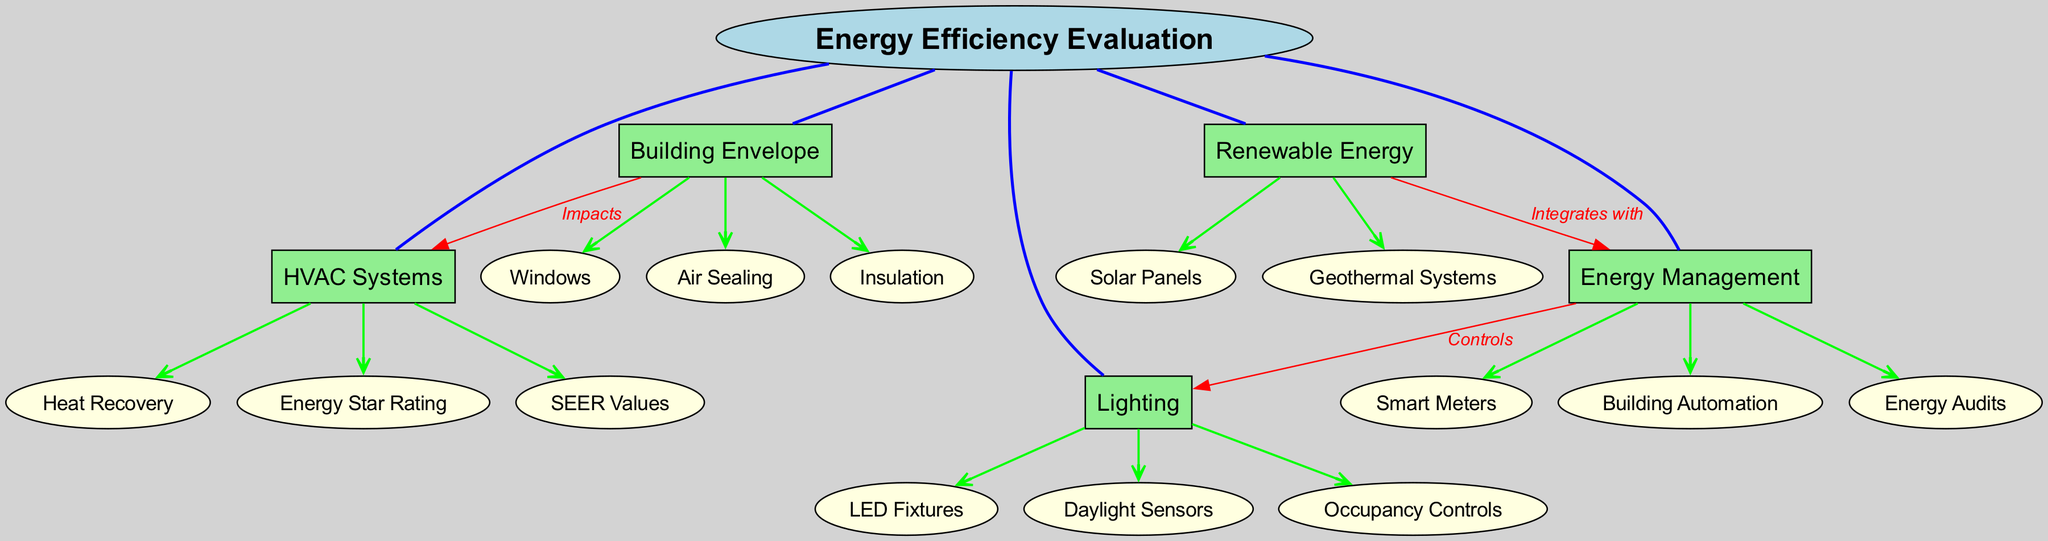What is the central concept of the diagram? The central concept is displayed prominently at the center of the diagram as "Energy Efficiency Evaluation".
Answer: Energy Efficiency Evaluation How many main categories are there? By counting the boxes branching out from the central concept, there are five main categories in total.
Answer: 5 Which subcategory is associated with "Building Envelope"? Looking under the "Building Envelope" category, "Insulation" is one of the subcategories listed.
Answer: Insulation What type of controls does "Energy Management" provide for "Lighting"? The connection from "Energy Management" to "Lighting" specifies that it provides "Controls" as identified in the diagram.
Answer: Controls Which renewable energy system is mentioned in the diagram? The "Renewable Energy" category lists "Solar Panels" as one of the systems described.
Answer: Solar Panels How does the "Building Envelope" impact "HVAC Systems"? The diagram states that "Building Envelope" has a direct impact on "HVAC Systems", indicating a relationship labeled as "Impacts".
Answer: Impacts What connects "Renewable Energy" and "Energy Management"? The diagram shows a relationship labeled "Integrates with" connecting "Renewable Energy" to "Energy Management".
Answer: Integrates with Which subcategory is related to occupancy in lighting? Under the "Lighting" category, "Occupancy Controls" is the subcategory that relates to occupancy.
Answer: Occupancy Controls What is the purpose of "Smart Meters" under "Energy Management"? While the diagram does not explicitly state, "Smart Meters" typically serve the purpose of monitoring and managing energy usage.
Answer: Monitoring and managing energy usage How many connections are shown between categories? By analyzing the connections drawn between the main categories, there are three connections indicated in the diagram.
Answer: 3 